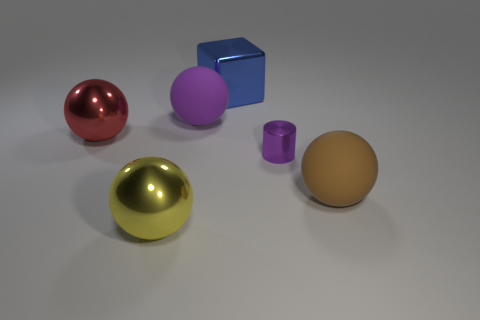Are there fewer large yellow metallic objects that are in front of the big yellow metal ball than cylinders?
Ensure brevity in your answer.  Yes. There is a rubber object behind the small object; what is its color?
Provide a short and direct response. Purple. Is there a purple thing that has the same shape as the red metal thing?
Your response must be concise. Yes. What number of big purple rubber objects have the same shape as the big brown matte object?
Provide a short and direct response. 1. Are there fewer small red cubes than large purple things?
Give a very brief answer. Yes. What material is the large purple thing that is behind the large brown matte sphere?
Your answer should be compact. Rubber. There is a blue object that is the same size as the yellow shiny thing; what material is it?
Make the answer very short. Metal. What is the ball that is right of the large rubber sphere left of the metal thing behind the big red thing made of?
Provide a succinct answer. Rubber. There is a red metallic thing left of the purple rubber sphere; does it have the same size as the brown matte object?
Your answer should be compact. Yes. Is the number of large blue shiny things greater than the number of spheres?
Provide a succinct answer. No. 